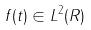<formula> <loc_0><loc_0><loc_500><loc_500>f ( t ) \in L ^ { 2 } ( R )</formula> 